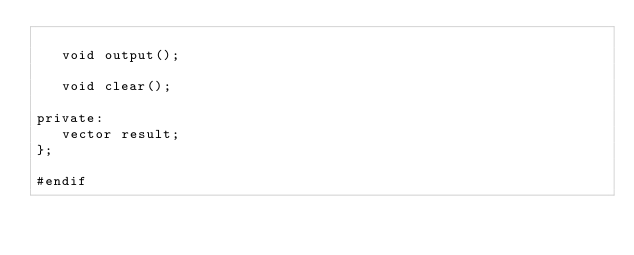<code> <loc_0><loc_0><loc_500><loc_500><_C_>
   void output();

   void clear();

private:
   vector result;
};

#endif </code> 